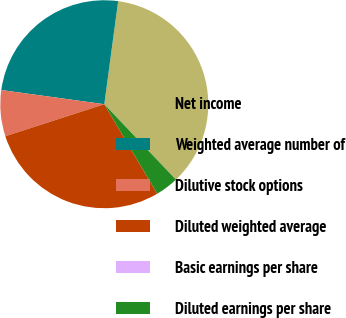<chart> <loc_0><loc_0><loc_500><loc_500><pie_chart><fcel>Net income<fcel>Weighted average number of<fcel>Dilutive stock options<fcel>Diluted weighted average<fcel>Basic earnings per share<fcel>Diluted earnings per share<nl><fcel>35.79%<fcel>24.95%<fcel>7.16%<fcel>28.53%<fcel>0.0%<fcel>3.58%<nl></chart> 